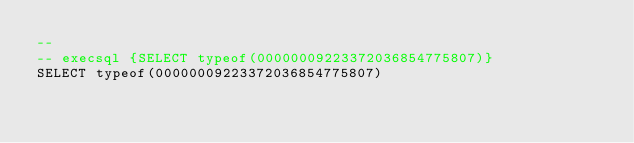<code> <loc_0><loc_0><loc_500><loc_500><_SQL_>-- 
-- execsql {SELECT typeof(00000009223372036854775807)}
SELECT typeof(00000009223372036854775807)</code> 